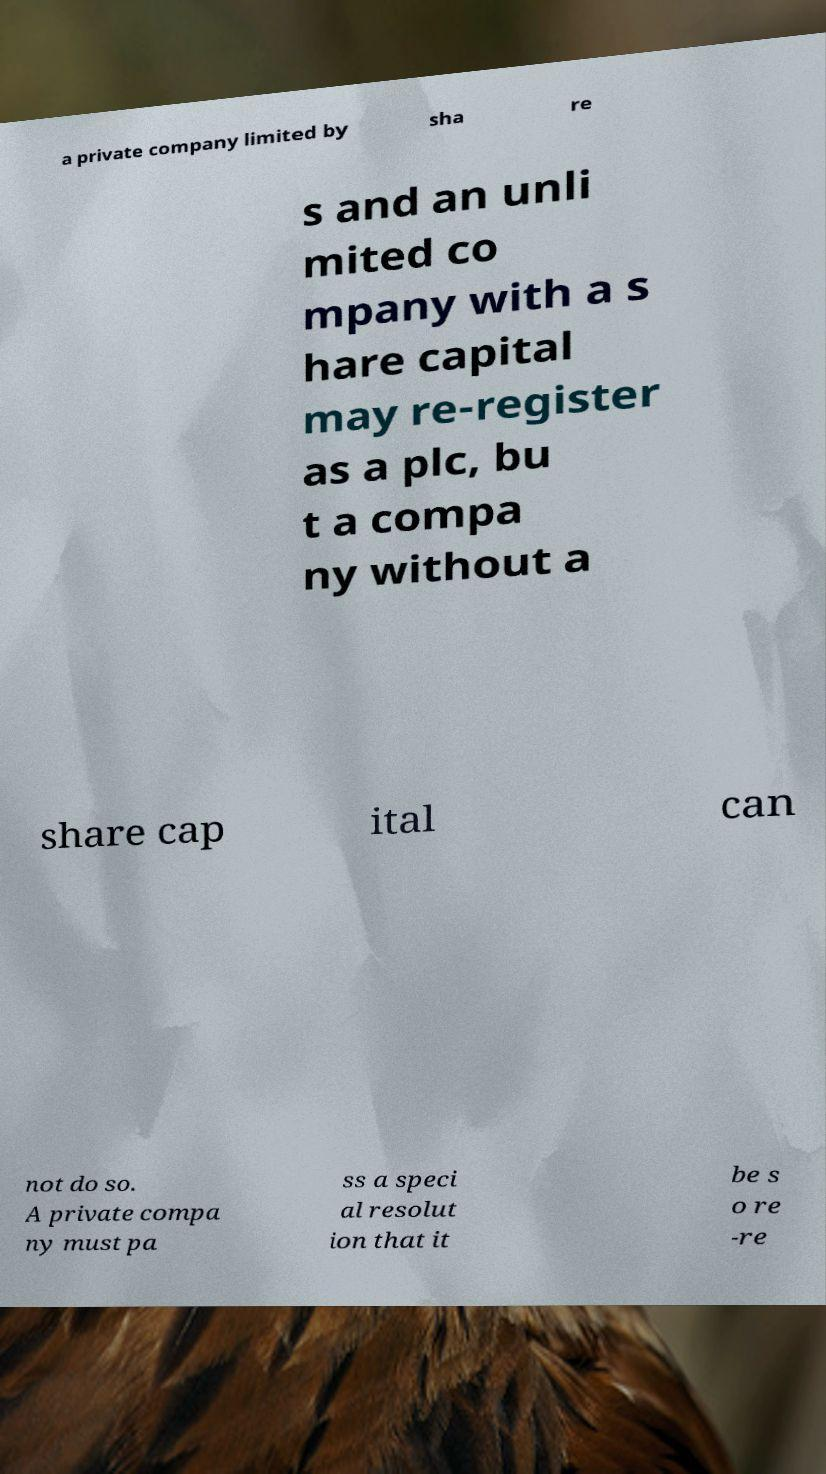There's text embedded in this image that I need extracted. Can you transcribe it verbatim? a private company limited by sha re s and an unli mited co mpany with a s hare capital may re-register as a plc, bu t a compa ny without a share cap ital can not do so. A private compa ny must pa ss a speci al resolut ion that it be s o re -re 